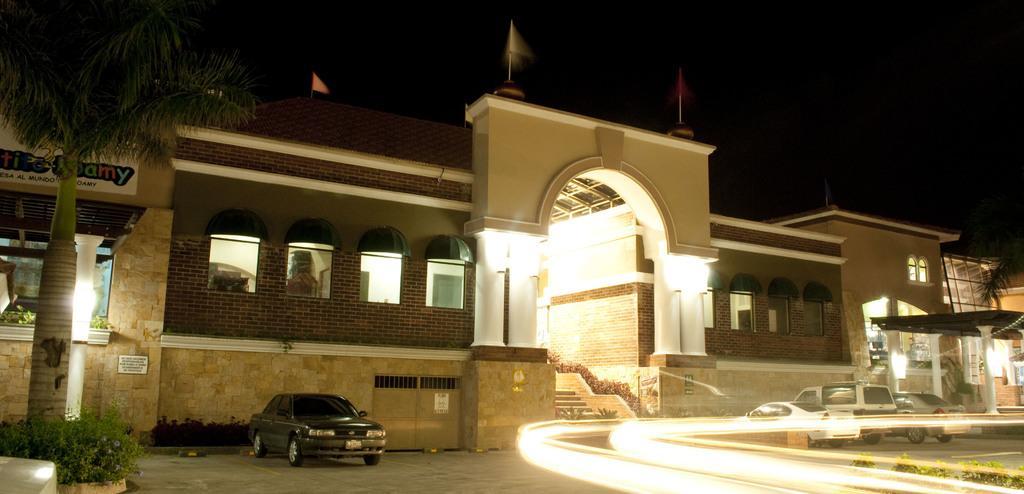How would you summarize this image in a sentence or two? In this image I can see the ground, few vehicles on the ground, few trees which are green in color, few lights, few stairs and few buildings. I can see few flags on the buildings and the dark sky in the background. 